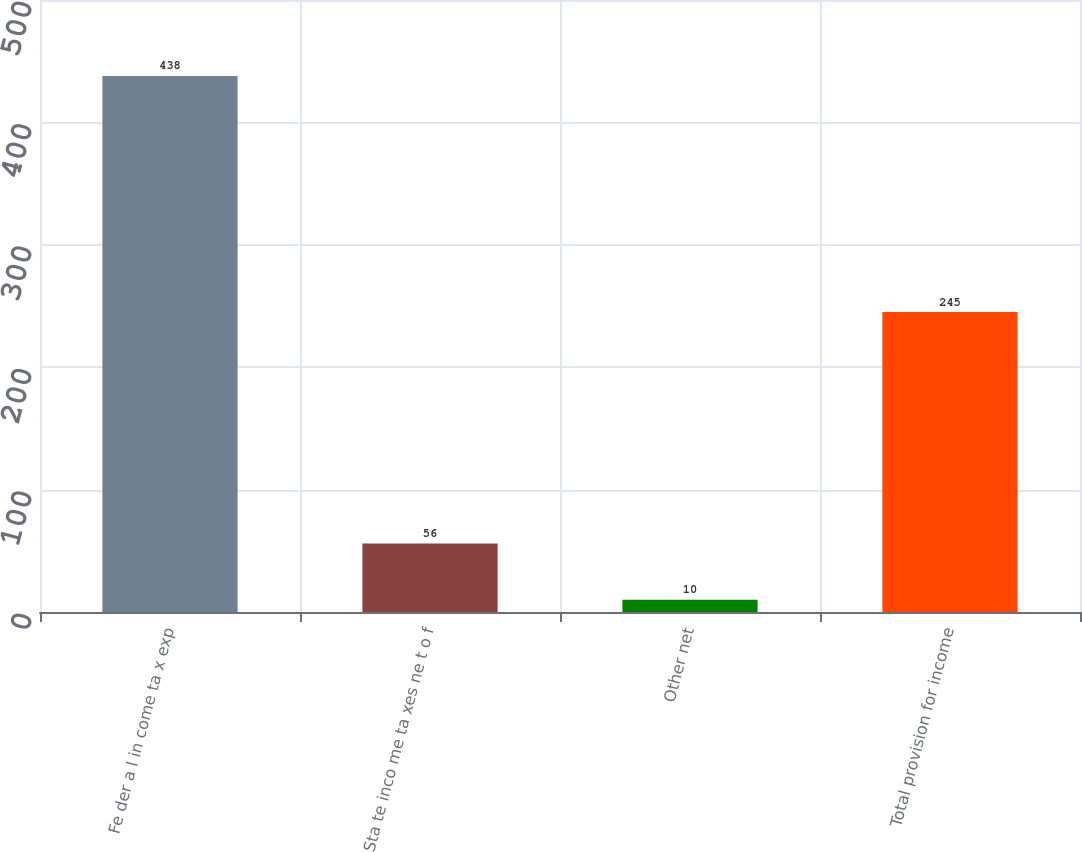Convert chart to OTSL. <chart><loc_0><loc_0><loc_500><loc_500><bar_chart><fcel>Fe der a l in come ta x exp<fcel>Sta te inco me ta xes ne t o f<fcel>Other net<fcel>Total provision for income<nl><fcel>438<fcel>56<fcel>10<fcel>245<nl></chart> 